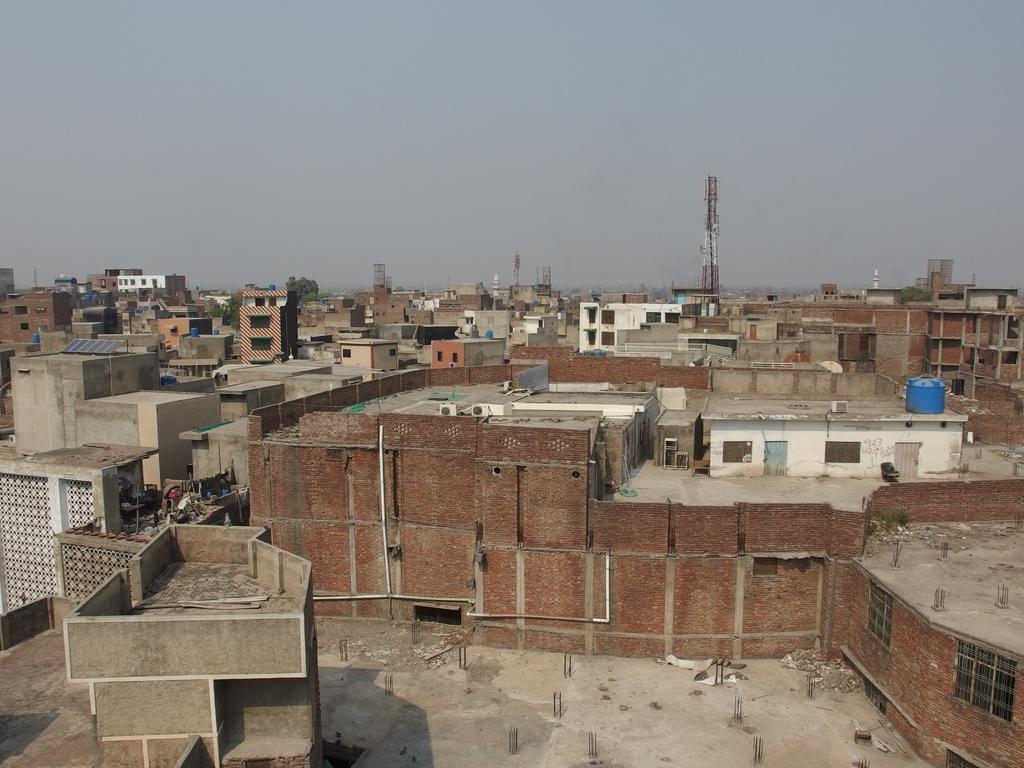How would you summarize this image in a sentence or two? There are many buildings with brick walls, pipes and windows. In the background there is sky. There are towers. There is a water tank on a building. 